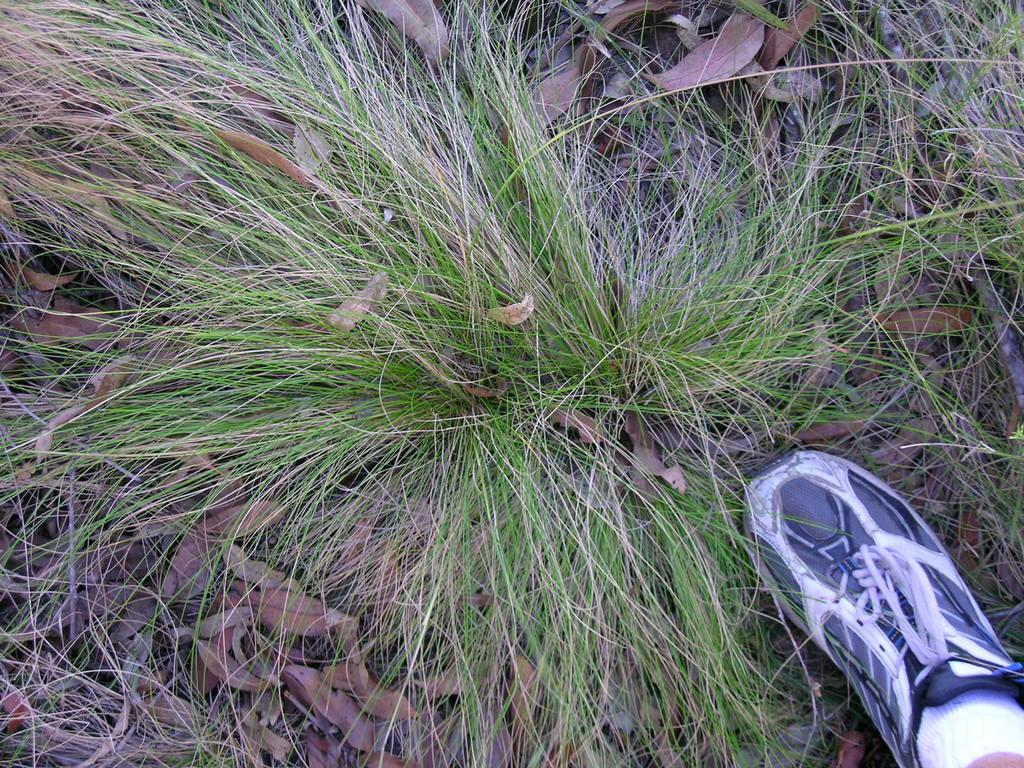What type of vegetation is present in the image? There are dried leaves and grass in the image. Can you describe the person's footwear in the image? A person is wearing a shoe in the image. What type of riddle is the person solving in the image? There is no indication of a riddle or any activity related to solving a riddle in the image. 